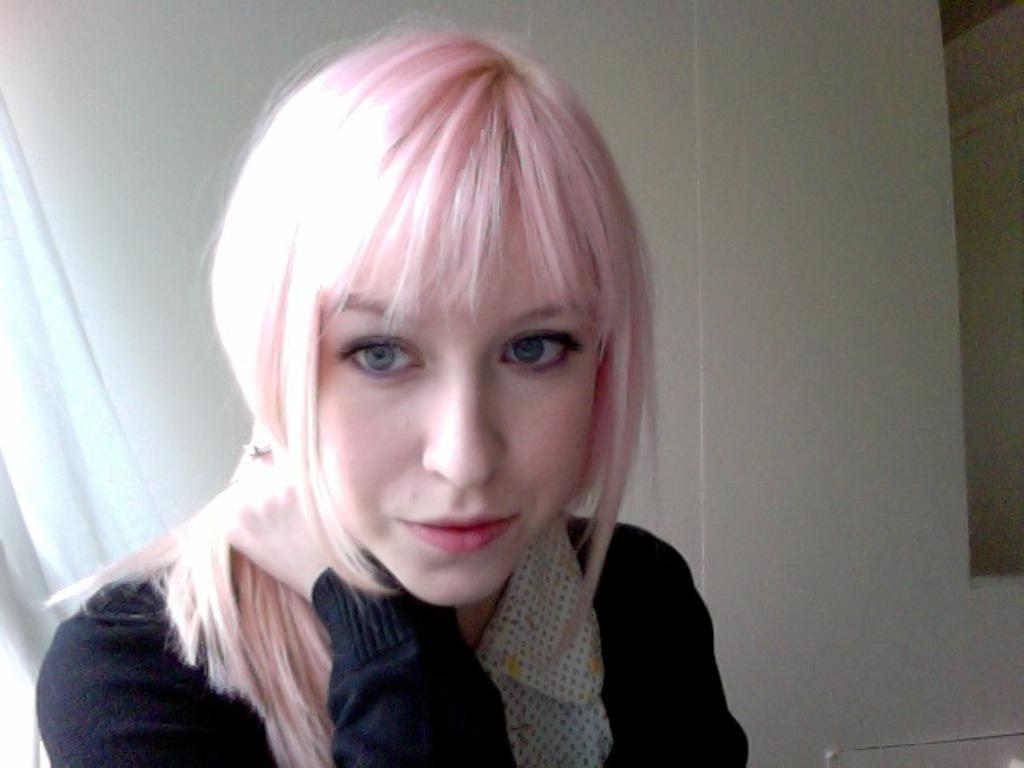Who is the main subject in the image? There is a girl in the center of the image. What is the girl wearing? The girl is wearing a black jacket. What can be seen in the background of the image? There is a wall in the background of the image. What type of powder is being used by the giraffe in the image? There is no giraffe present in the image, so it is not possible to determine if any powder is being used. 